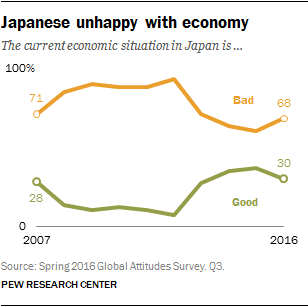Draw attention to some important aspects in this diagram. The sentiment that has a positive change from 2007 to 2016 is "good. 